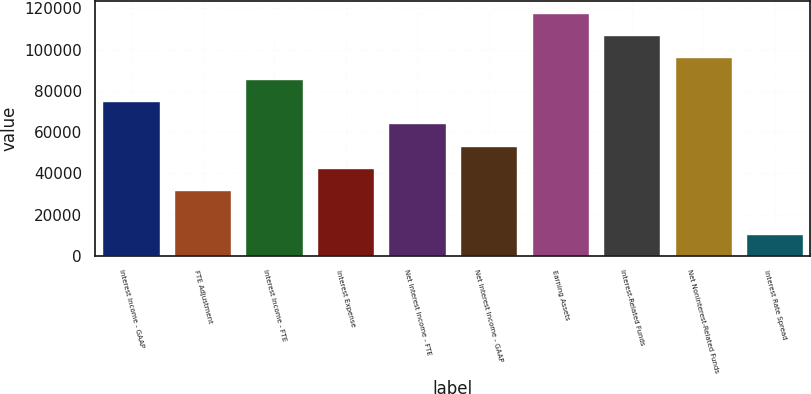Convert chart. <chart><loc_0><loc_0><loc_500><loc_500><bar_chart><fcel>Interest Income - GAAP<fcel>FTE Adjustment<fcel>Interest Income - FTE<fcel>Interest Expense<fcel>Net Interest Income - FTE<fcel>Net Interest Income - GAAP<fcel>Earning Assets<fcel>Interest-Related Funds<fcel>Net Noninterest-Related Funds<fcel>Interest Rate Spread<nl><fcel>74926.4<fcel>32111.4<fcel>85630.1<fcel>42815.1<fcel>64222.6<fcel>53518.9<fcel>117741<fcel>107038<fcel>96333.8<fcel>10703.9<nl></chart> 